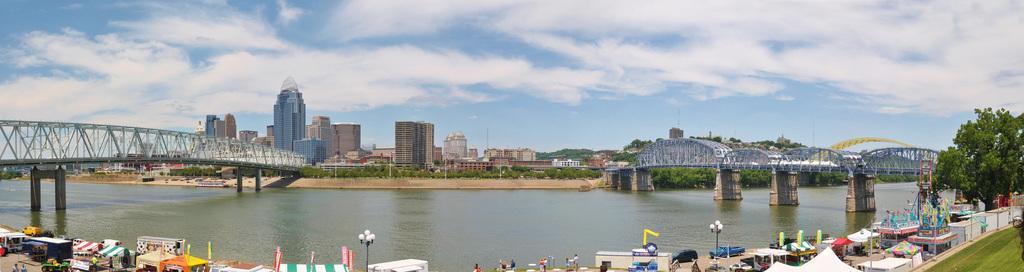Please provide a concise description of this image. In this image we can see bridges on the river, street vendors, street poles, street lights, persons standing on the road, buildings, skyscrapers, trees, parasols, advertisements, motor vehicles on the road, towers and sky with clouds. 